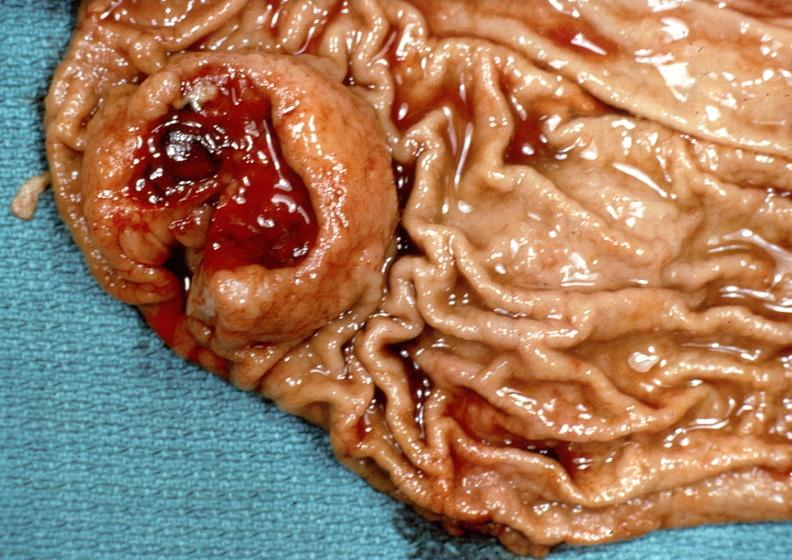what is present?
Answer the question using a single word or phrase. Gastrointestinal 